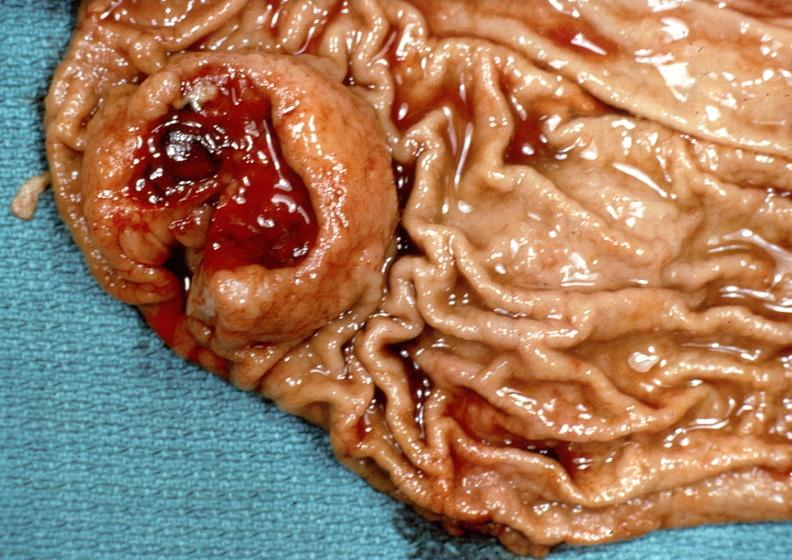what is present?
Answer the question using a single word or phrase. Gastrointestinal 